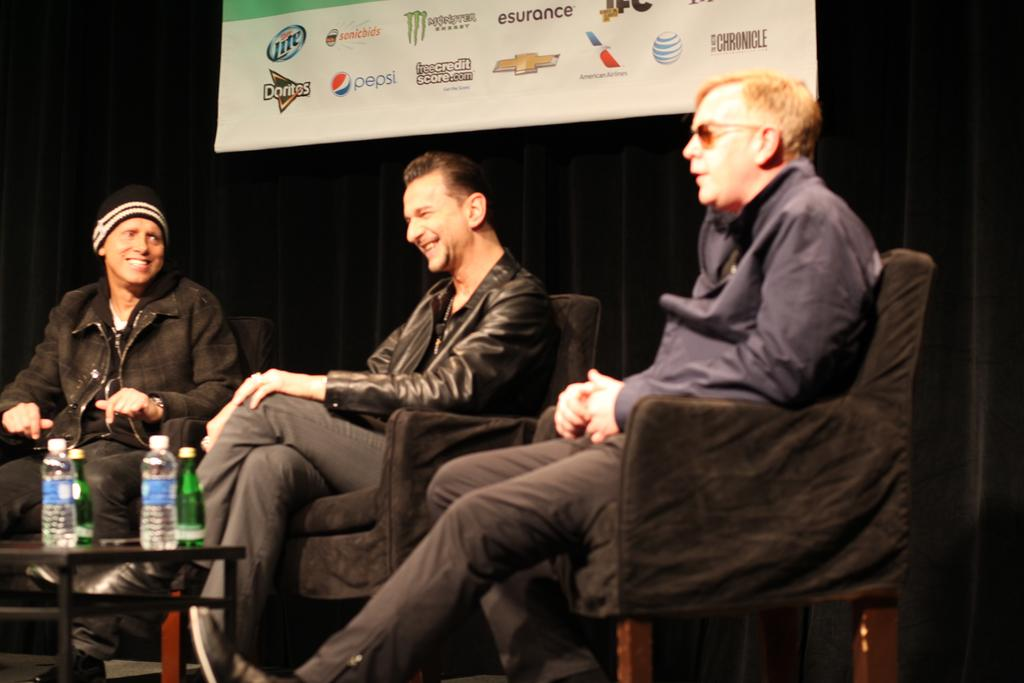How many people are in the image? There are three men in the image. What are the men doing in the image? The men are sitting on chairs. What is located in front of the men? There is a table in front of the men. What can be seen on the table? Water bottles are present on the table. What is the facial expression of the men? The men are smiling. What is on the wall behind the men? There is a banner on the wall behind the men. What type of boats can be seen in the image? There are no boats present in the image. What kind of teeth are visible on the men in the image? The men's teeth are not visible in the image. 